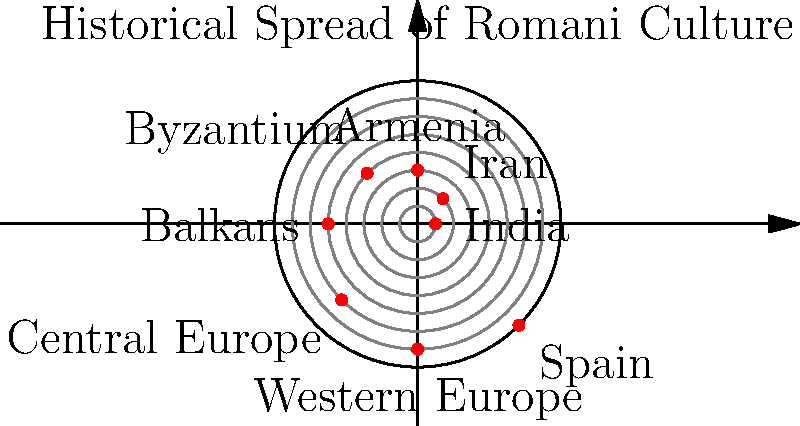In the polar coordinate representation of the historical spread of Romani culture from India, which region corresponds to the point $(r, \theta) = (5, \pi)$ in radians? To solve this problem, we need to follow these steps:

1. Understand the polar coordinate system:
   - $r$ represents the distance from the origin
   - $\theta$ represents the angle from the positive x-axis (counterclockwise)

2. Identify the given point:
   - $r = 5$
   - $\theta = \pi$ radians

3. Convert $\pi$ radians to degrees:
   - $\pi$ radians = 180°

4. Locate the point on the polar graph:
   - Distance from center: 5 units
   - Angle: 180°

5. Identify the region at this point:
   - Looking at the graph, we can see that the point $(5, 180°)$ corresponds to the "Balkans" region.

This representation shows the gradual spread of Romani culture from India (at the center) outwards through various regions, with the Balkans being a significant point in their historical journey across Europe.
Answer: Balkans 